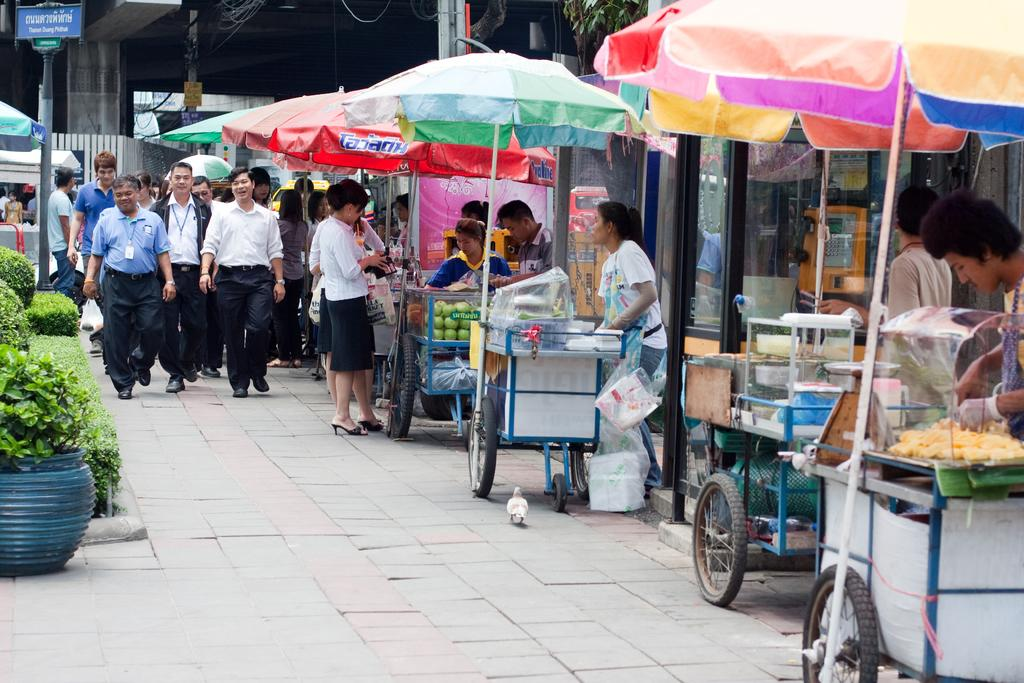What type of vehicles are in the image? There are trolleys in the image. What are the people in the image doing? People are walking on the road in the image. What type of decorative items can be seen in the image? Flower pots are visible in the image. What type of vegetation is present in the image? Shrubs are present in the image. What objects might be used for protection from the elements in the image? Umbrellas are in the image. What type of signage is present in the image? There is a board attached to a pole in the image. What type of structure is visible in the background of the image? A building is visible in the background of the image. How many threads are visible on the trolleys in the image? There is no mention of threads in the image, and therefore no such detail can be observed. What type of structure is the crib in the image? There is no crib present in the image. 